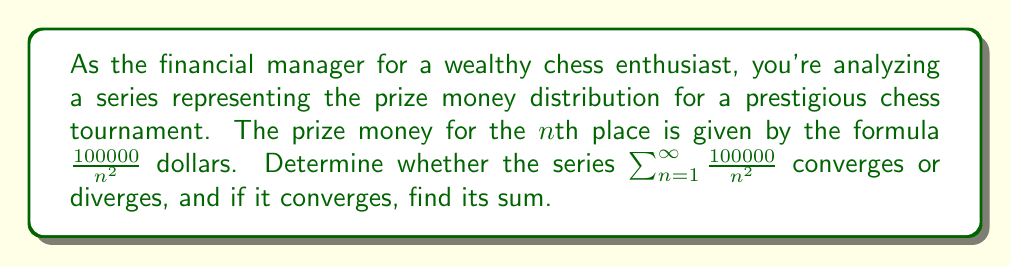Can you solve this math problem? Let's approach this step-by-step:

1) First, we need to recognize that this series is a scalar multiple of the p-series $\sum_{n=1}^{\infty} \frac{1}{n^p}$ with $p=2$ and a scalar of 100000.

2) We know that p-series converge for $p > 1$ and diverge for $p \leq 1$. In this case, $p = 2 > 1$, so the series converges.

3) To find the sum, we can use the fact that for the p-series with $p=2$:

   $$\sum_{n=1}^{\infty} \frac{1}{n^2} = \frac{\pi^2}{6}$$

   This is a well-known result, often referred to as the Basel problem.

4) Our series is 100000 times this sum, so:

   $$\sum_{n=1}^{\infty} \frac{100000}{n^2} = 100000 \cdot \sum_{n=1}^{\infty} \frac{1}{n^2} = 100000 \cdot \frac{\pi^2}{6}$$

5) We can calculate this:

   $$100000 \cdot \frac{\pi^2}{6} \approx 164493.40668$$

Therefore, the series converges to approximately $164493.41 dollars.
Answer: The series converges and its sum is $\frac{100000\pi^2}{6} \approx 164493.41$ dollars. 